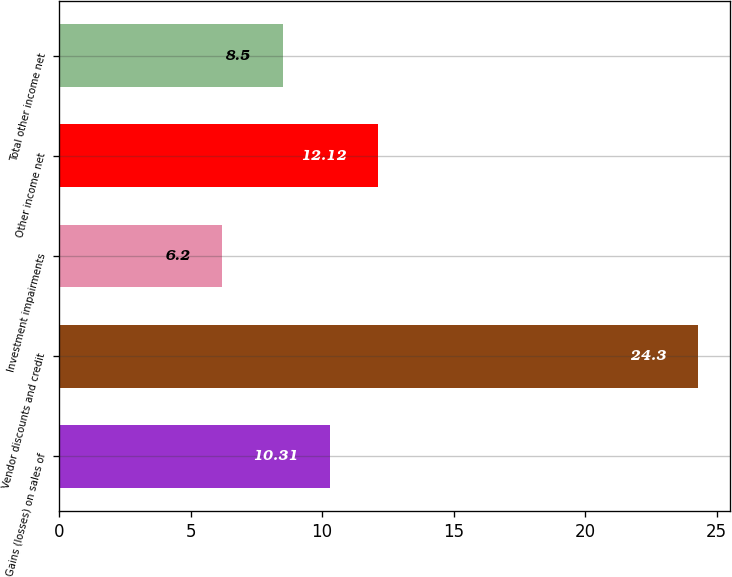Convert chart to OTSL. <chart><loc_0><loc_0><loc_500><loc_500><bar_chart><fcel>Gains (losses) on sales of<fcel>Vendor discounts and credit<fcel>Investment impairments<fcel>Other income net<fcel>Total other income net<nl><fcel>10.31<fcel>24.3<fcel>6.2<fcel>12.12<fcel>8.5<nl></chart> 